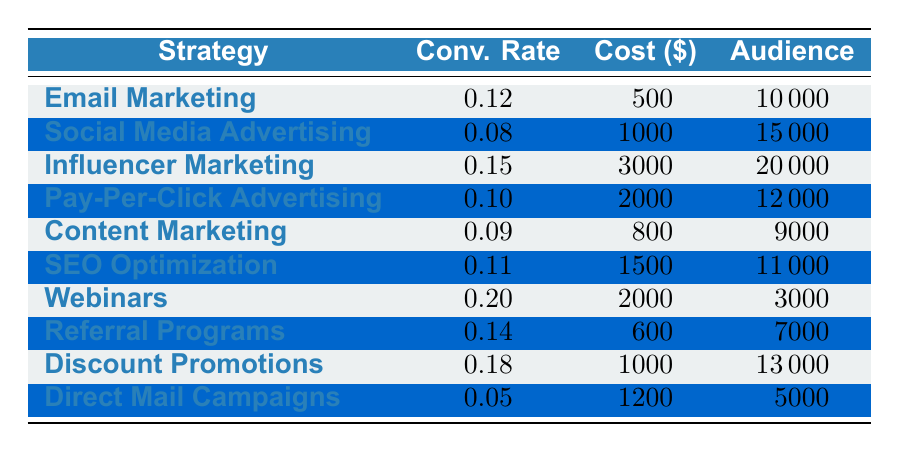What is the conversion rate of Webinars? The table lists the conversion rate for each promotional strategy. For Webinars, it is directly stated as 0.20.
Answer: 0.20 Which promotional strategy has the highest conversion rate? By examining the conversion rates in the table, Webinars have the highest rate at 0.20 compared to all other strategies listed.
Answer: Webinars What is the total campaign cost for Email Marketing and Referral Programs? The campaign cost for Email Marketing is 500, and for Referral Programs, it is 600. Adding both gives us 500 + 600 = 1100.
Answer: 1100 Is the conversion rate for Social Media Advertising greater than 0.10? The conversion rate for Social Media Advertising is 0.08, which is less than 0.10. Therefore, the answer is no.
Answer: No What is the average conversion rate of Influencer Marketing and Discount Promotions? The conversion rates are 0.15 for Influencer Marketing and 0.18 for Discount Promotions. To find the average, calculate (0.15 + 0.18) / 2 = 0.165.
Answer: 0.165 How many promotional strategies have a conversion rate greater than 0.10? The strategies with conversion rates above 0.10 are Influencer Marketing (0.15), Webinars (0.20), Referral Programs (0.14), and Discount Promotions (0.18). This makes a total of 4 strategies.
Answer: 4 What is the target audience size of the strategy with the least conversion rate? The strategy with the least conversion rate is Direct Mail Campaigns at 0.05, which has a target audience size of 5000.
Answer: 5000 Which costs more, SEO Optimization or Pay-Per-Click Advertising? The costs are 1500 for SEO Optimization and 2000 for Pay-Per-Click Advertising. Since 2000 is greater than 1500, Pay-Per-Click Advertising costs more.
Answer: Pay-Per-Click Advertising If I want to maximize conversion rate with a budget of 1000, which strategy should I choose? The strategies within the budget of 1000 are Email Marketing (0.12) and Social Media Advertising (0.08). The best conversion rate among those is Email Marketing at 0.12, so that should be chosen.
Answer: Email Marketing 